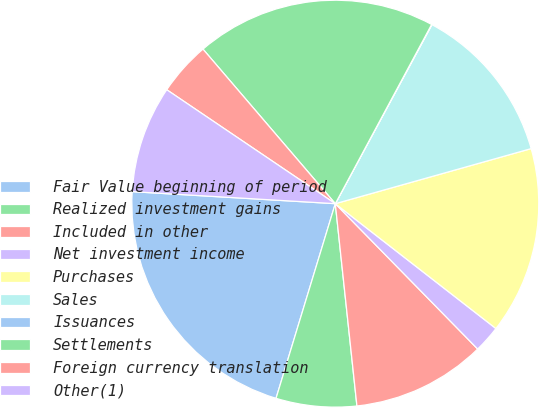Convert chart. <chart><loc_0><loc_0><loc_500><loc_500><pie_chart><fcel>Fair Value beginning of period<fcel>Realized investment gains<fcel>Included in other<fcel>Net investment income<fcel>Purchases<fcel>Sales<fcel>Issuances<fcel>Settlements<fcel>Foreign currency translation<fcel>Other(1)<nl><fcel>21.24%<fcel>6.4%<fcel>10.64%<fcel>2.15%<fcel>14.88%<fcel>12.76%<fcel>0.03%<fcel>19.12%<fcel>4.27%<fcel>8.52%<nl></chart> 